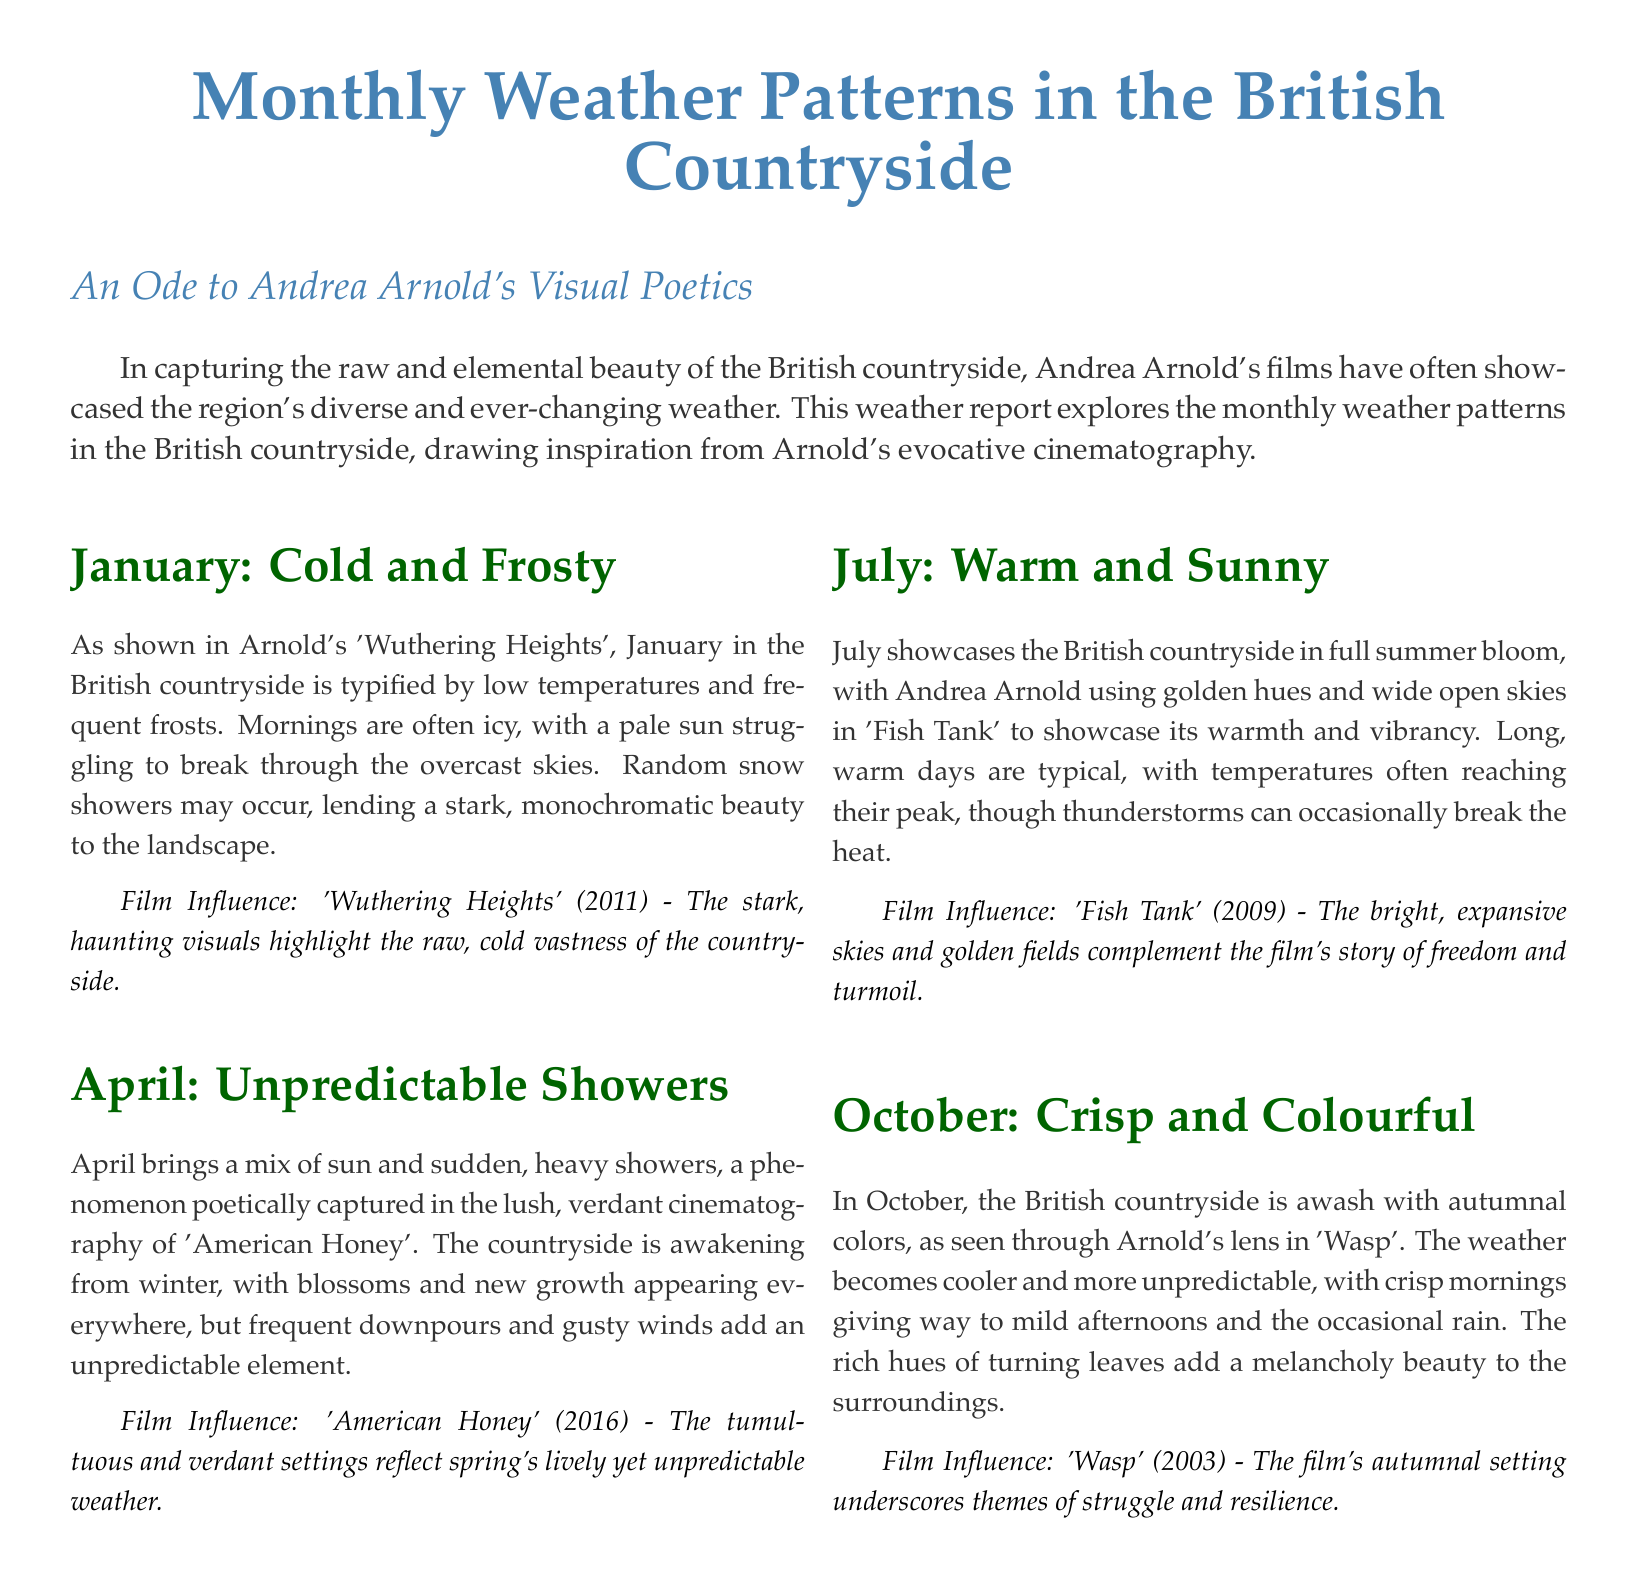What month is described as 'Cold and Frosty'? The document specifically describes January as 'Cold and Frosty'.
Answer: January Which film is referenced for April's weather? The film mentioned in connection with April's weather is 'American Honey'.
Answer: American Honey What is the typical weather condition for July? The document states that July is characterized as 'Warm and Sunny'.
Answer: Warm and Sunny How does October's weather contribute to the overall setting in the document? October's crisp weather and colorful landscape enhance the film's themes of struggle and resilience as seen in 'Wasp'.
Answer: Struggle and resilience What type of weather is typical in April according to the document? April is described as having 'Unpredictable Showers'.
Answer: Unpredictable Showers Which film showcases the summer weather in the countryside? The film 'Fish Tank' is highlighted for its portrayal of summer weather.
Answer: Fish Tank What is a notable feature of October's weather patterns? October is noted for cooler and more unpredictable weather.
Answer: Cooler and more unpredictable How are frosty mornings depicted in January? The frosty mornings in January are described as having a pale sun struggling to break through overcast skies.
Answer: Pale sun, overcast skies What seasonal changes happen in the British countryside by April? By April, the countryside awakens from winter with blossoms and new growth.
Answer: Blossoms and new growth 